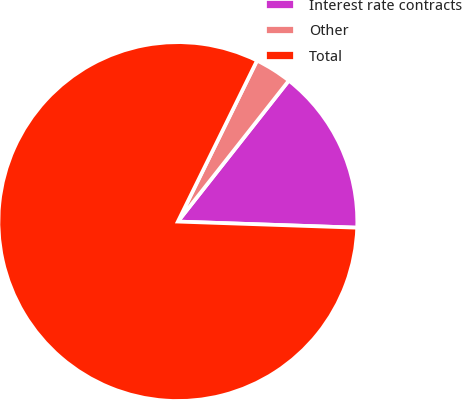Convert chart to OTSL. <chart><loc_0><loc_0><loc_500><loc_500><pie_chart><fcel>Interest rate contracts<fcel>Other<fcel>Total<nl><fcel>14.93%<fcel>3.34%<fcel>81.73%<nl></chart> 